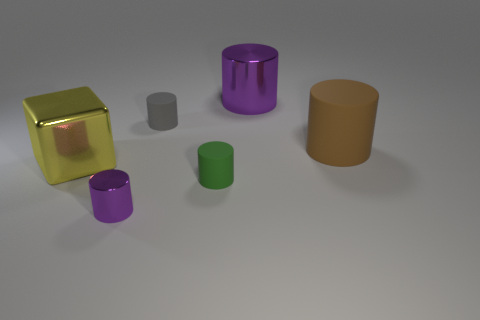There is a small object that is to the left of the gray cylinder; is its color the same as the large metal cylinder?
Offer a very short reply. Yes. Do the large metallic cylinder and the tiny metallic object have the same color?
Give a very brief answer. Yes. How many things are metallic objects to the left of the small green matte object or small green matte things?
Offer a terse response. 3. What is the color of the other tiny rubber thing that is the same shape as the tiny green matte object?
Your response must be concise. Gray. Is the shape of the green thing the same as the large metallic thing right of the small gray cylinder?
Provide a short and direct response. Yes. What number of objects are either small cylinders that are in front of the big metallic cube or big objects that are on the right side of the large metal block?
Offer a terse response. 4. Is the number of objects that are in front of the big yellow thing less than the number of tiny cyan metal cubes?
Your answer should be very brief. No. Is the gray thing made of the same material as the large object to the right of the big purple cylinder?
Provide a succinct answer. Yes. What is the material of the small gray object?
Your response must be concise. Rubber. What material is the purple object in front of the purple metallic cylinder that is behind the purple cylinder that is on the left side of the green cylinder made of?
Your answer should be very brief. Metal. 